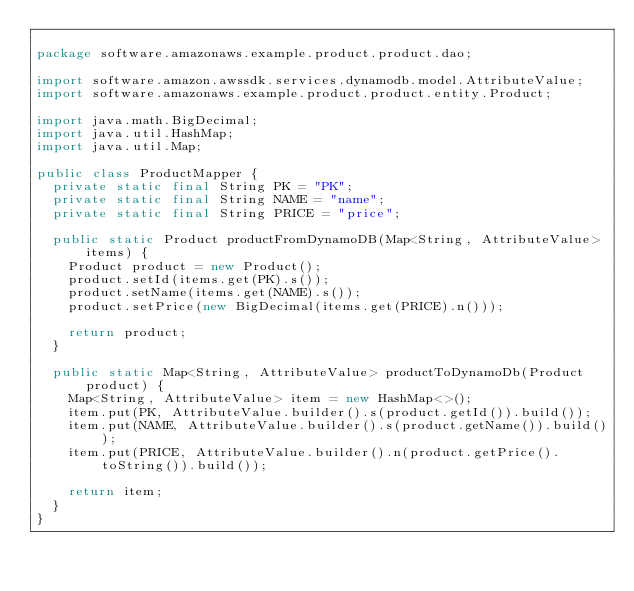Convert code to text. <code><loc_0><loc_0><loc_500><loc_500><_Java_>
package software.amazonaws.example.product.product.dao;

import software.amazon.awssdk.services.dynamodb.model.AttributeValue;
import software.amazonaws.example.product.product.entity.Product;

import java.math.BigDecimal;
import java.util.HashMap;
import java.util.Map;

public class ProductMapper {
  private static final String PK = "PK";
  private static final String NAME = "name";
  private static final String PRICE = "price";

  public static Product productFromDynamoDB(Map<String, AttributeValue> items) {
    Product product = new Product();
    product.setId(items.get(PK).s());
    product.setName(items.get(NAME).s());
    product.setPrice(new BigDecimal(items.get(PRICE).n()));

    return product;
  }

  public static Map<String, AttributeValue> productToDynamoDb(Product product) {
    Map<String, AttributeValue> item = new HashMap<>();
    item.put(PK, AttributeValue.builder().s(product.getId()).build());
    item.put(NAME, AttributeValue.builder().s(product.getName()).build());
    item.put(PRICE, AttributeValue.builder().n(product.getPrice().toString()).build());

    return item;
  }
}
</code> 